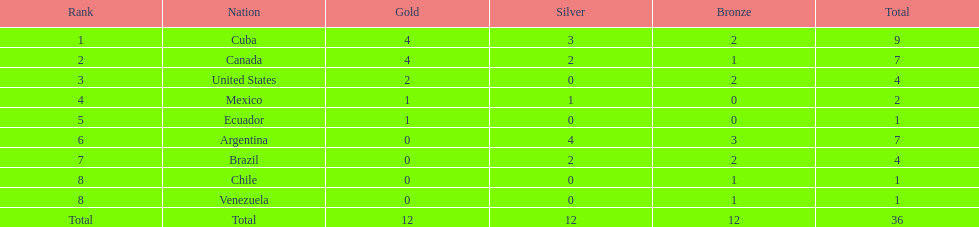What is the overall count of countries that failed to secure gold? 4. 